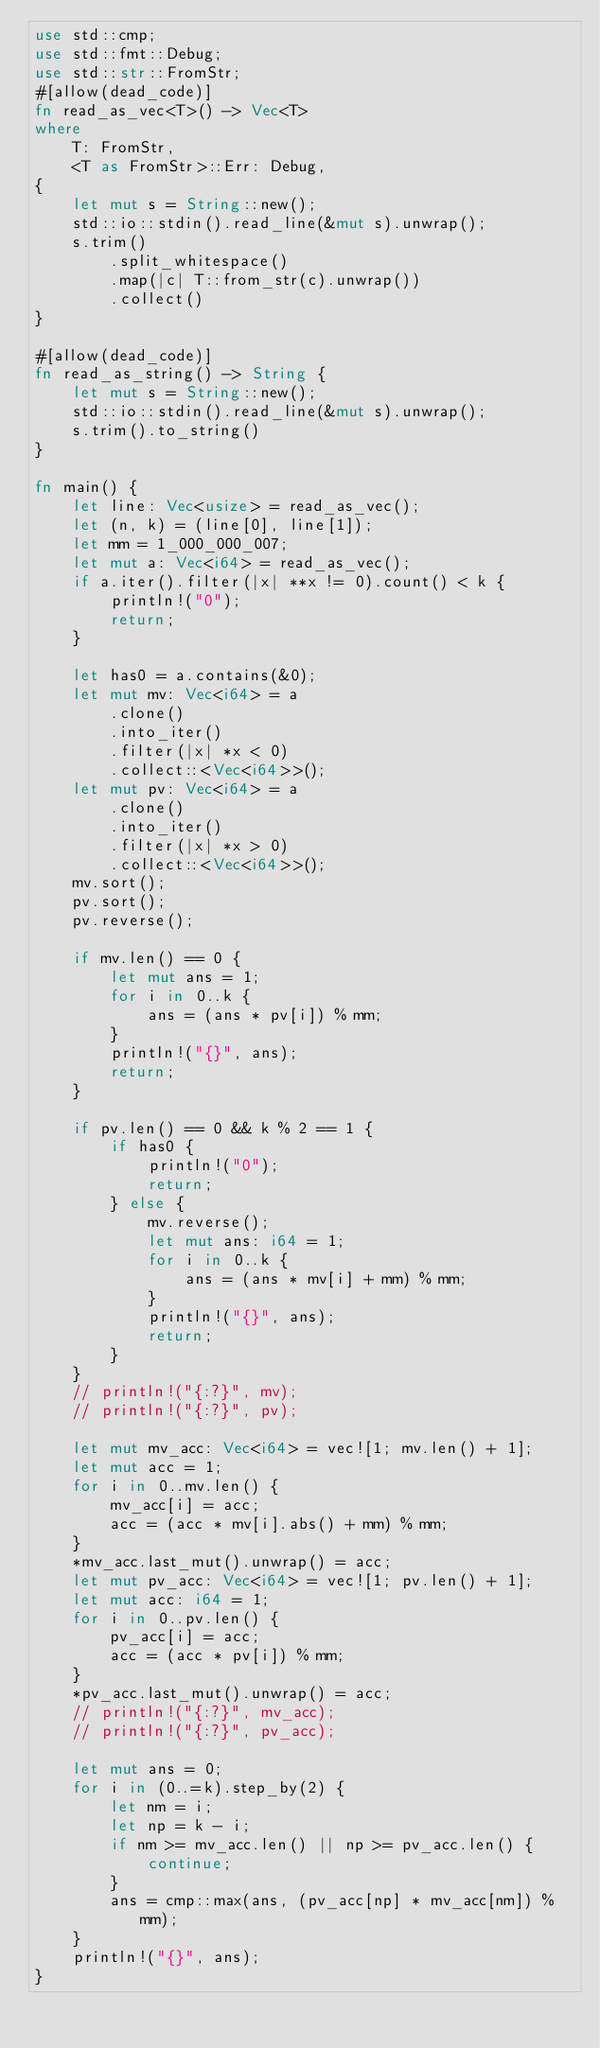<code> <loc_0><loc_0><loc_500><loc_500><_Rust_>use std::cmp;
use std::fmt::Debug;
use std::str::FromStr;
#[allow(dead_code)]
fn read_as_vec<T>() -> Vec<T>
where
    T: FromStr,
    <T as FromStr>::Err: Debug,
{
    let mut s = String::new();
    std::io::stdin().read_line(&mut s).unwrap();
    s.trim()
        .split_whitespace()
        .map(|c| T::from_str(c).unwrap())
        .collect()
}

#[allow(dead_code)]
fn read_as_string() -> String {
    let mut s = String::new();
    std::io::stdin().read_line(&mut s).unwrap();
    s.trim().to_string()
}

fn main() {
    let line: Vec<usize> = read_as_vec();
    let (n, k) = (line[0], line[1]);
    let mm = 1_000_000_007;
    let mut a: Vec<i64> = read_as_vec();
    if a.iter().filter(|x| **x != 0).count() < k {
        println!("0");
        return;
    }

    let has0 = a.contains(&0);
    let mut mv: Vec<i64> = a
        .clone()
        .into_iter()
        .filter(|x| *x < 0)
        .collect::<Vec<i64>>();
    let mut pv: Vec<i64> = a
        .clone()
        .into_iter()
        .filter(|x| *x > 0)
        .collect::<Vec<i64>>();
    mv.sort();
    pv.sort();
    pv.reverse();

    if mv.len() == 0 {
        let mut ans = 1;
        for i in 0..k {
            ans = (ans * pv[i]) % mm;
        }
        println!("{}", ans);
        return;
    }

    if pv.len() == 0 && k % 2 == 1 {
        if has0 {
            println!("0");
            return;
        } else {
            mv.reverse();
            let mut ans: i64 = 1;
            for i in 0..k {
                ans = (ans * mv[i] + mm) % mm;
            }
            println!("{}", ans);
            return;
        }
    }
    // println!("{:?}", mv);
    // println!("{:?}", pv);

    let mut mv_acc: Vec<i64> = vec![1; mv.len() + 1];
    let mut acc = 1;
    for i in 0..mv.len() {
        mv_acc[i] = acc;
        acc = (acc * mv[i].abs() + mm) % mm;
    }
    *mv_acc.last_mut().unwrap() = acc;
    let mut pv_acc: Vec<i64> = vec![1; pv.len() + 1];
    let mut acc: i64 = 1;
    for i in 0..pv.len() {
        pv_acc[i] = acc;
        acc = (acc * pv[i]) % mm;
    }
    *pv_acc.last_mut().unwrap() = acc;
    // println!("{:?}", mv_acc);
    // println!("{:?}", pv_acc);

    let mut ans = 0;
    for i in (0..=k).step_by(2) {
        let nm = i;
        let np = k - i;
        if nm >= mv_acc.len() || np >= pv_acc.len() {
            continue;
        }
        ans = cmp::max(ans, (pv_acc[np] * mv_acc[nm]) % mm);
    }
    println!("{}", ans);
}
</code> 